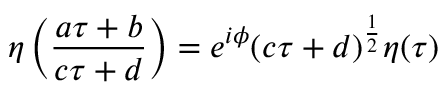<formula> <loc_0><loc_0><loc_500><loc_500>\eta \left ( \frac { a \tau + b } { c \tau + d } \right ) = e ^ { i \phi } ( c \tau + d ) ^ { \frac { 1 } { 2 } } \eta ( \tau )</formula> 